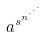Convert formula to latex. <formula><loc_0><loc_0><loc_500><loc_500>a ^ { s ^ { n ^ { \cdot ^ { \cdot ^ { \cdot } } } } }</formula> 